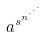Convert formula to latex. <formula><loc_0><loc_0><loc_500><loc_500>a ^ { s ^ { n ^ { \cdot ^ { \cdot ^ { \cdot } } } } }</formula> 